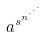Convert formula to latex. <formula><loc_0><loc_0><loc_500><loc_500>a ^ { s ^ { n ^ { \cdot ^ { \cdot ^ { \cdot } } } } }</formula> 